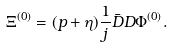<formula> <loc_0><loc_0><loc_500><loc_500>\Xi ^ { ( 0 ) } = ( p + \eta ) \frac { 1 } { j } \bar { D } D \Phi ^ { ( 0 ) } .</formula> 